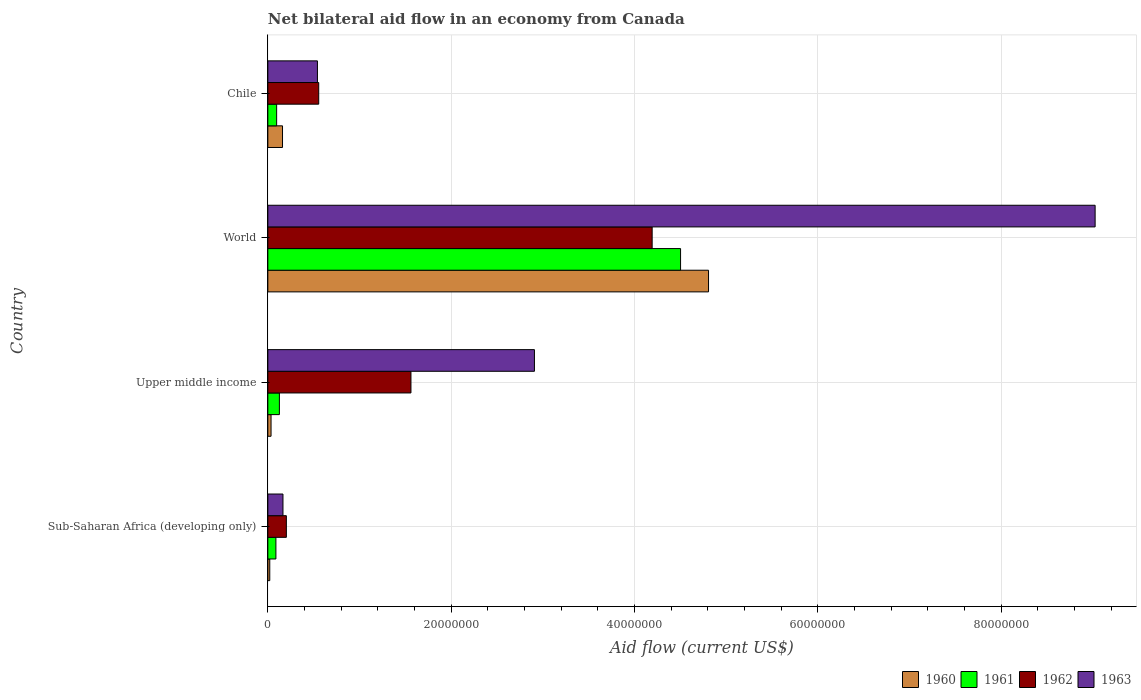Are the number of bars per tick equal to the number of legend labels?
Offer a very short reply. Yes. Are the number of bars on each tick of the Y-axis equal?
Your answer should be very brief. Yes. How many bars are there on the 2nd tick from the top?
Offer a terse response. 4. In how many cases, is the number of bars for a given country not equal to the number of legend labels?
Your response must be concise. 0. What is the net bilateral aid flow in 1963 in World?
Make the answer very short. 9.02e+07. Across all countries, what is the maximum net bilateral aid flow in 1963?
Offer a very short reply. 9.02e+07. Across all countries, what is the minimum net bilateral aid flow in 1962?
Offer a terse response. 2.02e+06. In which country was the net bilateral aid flow in 1962 minimum?
Make the answer very short. Sub-Saharan Africa (developing only). What is the total net bilateral aid flow in 1961 in the graph?
Keep it short and to the point. 4.81e+07. What is the difference between the net bilateral aid flow in 1960 in Chile and that in World?
Your answer should be very brief. -4.65e+07. What is the difference between the net bilateral aid flow in 1962 in World and the net bilateral aid flow in 1961 in Upper middle income?
Offer a terse response. 4.07e+07. What is the average net bilateral aid flow in 1960 per country?
Provide a short and direct response. 1.26e+07. What is the difference between the net bilateral aid flow in 1962 and net bilateral aid flow in 1961 in Chile?
Offer a terse response. 4.59e+06. In how many countries, is the net bilateral aid flow in 1963 greater than 88000000 US$?
Offer a terse response. 1. What is the ratio of the net bilateral aid flow in 1962 in Sub-Saharan Africa (developing only) to that in World?
Your answer should be compact. 0.05. Is the net bilateral aid flow in 1962 in Chile less than that in Sub-Saharan Africa (developing only)?
Your answer should be compact. No. Is the difference between the net bilateral aid flow in 1962 in Sub-Saharan Africa (developing only) and World greater than the difference between the net bilateral aid flow in 1961 in Sub-Saharan Africa (developing only) and World?
Your response must be concise. Yes. What is the difference between the highest and the second highest net bilateral aid flow in 1961?
Provide a short and direct response. 4.38e+07. What is the difference between the highest and the lowest net bilateral aid flow in 1961?
Provide a short and direct response. 4.41e+07. In how many countries, is the net bilateral aid flow in 1962 greater than the average net bilateral aid flow in 1962 taken over all countries?
Your answer should be very brief. 1. Is the sum of the net bilateral aid flow in 1963 in Chile and World greater than the maximum net bilateral aid flow in 1962 across all countries?
Make the answer very short. Yes. Is it the case that in every country, the sum of the net bilateral aid flow in 1960 and net bilateral aid flow in 1963 is greater than the sum of net bilateral aid flow in 1961 and net bilateral aid flow in 1962?
Offer a very short reply. No. What does the 4th bar from the top in Chile represents?
Your answer should be compact. 1960. Is it the case that in every country, the sum of the net bilateral aid flow in 1962 and net bilateral aid flow in 1963 is greater than the net bilateral aid flow in 1961?
Keep it short and to the point. Yes. How many countries are there in the graph?
Provide a short and direct response. 4. Does the graph contain any zero values?
Keep it short and to the point. No. Does the graph contain grids?
Make the answer very short. Yes. How are the legend labels stacked?
Your response must be concise. Horizontal. What is the title of the graph?
Your answer should be compact. Net bilateral aid flow in an economy from Canada. Does "1996" appear as one of the legend labels in the graph?
Provide a succinct answer. No. What is the label or title of the X-axis?
Offer a terse response. Aid flow (current US$). What is the Aid flow (current US$) in 1961 in Sub-Saharan Africa (developing only)?
Offer a terse response. 8.80e+05. What is the Aid flow (current US$) of 1962 in Sub-Saharan Africa (developing only)?
Make the answer very short. 2.02e+06. What is the Aid flow (current US$) of 1963 in Sub-Saharan Africa (developing only)?
Your answer should be compact. 1.65e+06. What is the Aid flow (current US$) of 1960 in Upper middle income?
Make the answer very short. 3.50e+05. What is the Aid flow (current US$) in 1961 in Upper middle income?
Ensure brevity in your answer.  1.26e+06. What is the Aid flow (current US$) of 1962 in Upper middle income?
Make the answer very short. 1.56e+07. What is the Aid flow (current US$) in 1963 in Upper middle income?
Keep it short and to the point. 2.91e+07. What is the Aid flow (current US$) in 1960 in World?
Offer a very short reply. 4.81e+07. What is the Aid flow (current US$) of 1961 in World?
Keep it short and to the point. 4.50e+07. What is the Aid flow (current US$) of 1962 in World?
Provide a succinct answer. 4.19e+07. What is the Aid flow (current US$) of 1963 in World?
Ensure brevity in your answer.  9.02e+07. What is the Aid flow (current US$) of 1960 in Chile?
Keep it short and to the point. 1.60e+06. What is the Aid flow (current US$) in 1961 in Chile?
Keep it short and to the point. 9.60e+05. What is the Aid flow (current US$) of 1962 in Chile?
Your response must be concise. 5.55e+06. What is the Aid flow (current US$) of 1963 in Chile?
Give a very brief answer. 5.41e+06. Across all countries, what is the maximum Aid flow (current US$) of 1960?
Your answer should be very brief. 4.81e+07. Across all countries, what is the maximum Aid flow (current US$) of 1961?
Make the answer very short. 4.50e+07. Across all countries, what is the maximum Aid flow (current US$) of 1962?
Offer a terse response. 4.19e+07. Across all countries, what is the maximum Aid flow (current US$) of 1963?
Provide a short and direct response. 9.02e+07. Across all countries, what is the minimum Aid flow (current US$) in 1960?
Give a very brief answer. 2.10e+05. Across all countries, what is the minimum Aid flow (current US$) in 1961?
Your answer should be compact. 8.80e+05. Across all countries, what is the minimum Aid flow (current US$) of 1962?
Your response must be concise. 2.02e+06. Across all countries, what is the minimum Aid flow (current US$) of 1963?
Your answer should be very brief. 1.65e+06. What is the total Aid flow (current US$) in 1960 in the graph?
Make the answer very short. 5.02e+07. What is the total Aid flow (current US$) in 1961 in the graph?
Give a very brief answer. 4.81e+07. What is the total Aid flow (current US$) of 1962 in the graph?
Provide a short and direct response. 6.51e+07. What is the total Aid flow (current US$) of 1963 in the graph?
Your response must be concise. 1.26e+08. What is the difference between the Aid flow (current US$) in 1960 in Sub-Saharan Africa (developing only) and that in Upper middle income?
Make the answer very short. -1.40e+05. What is the difference between the Aid flow (current US$) in 1961 in Sub-Saharan Africa (developing only) and that in Upper middle income?
Give a very brief answer. -3.80e+05. What is the difference between the Aid flow (current US$) in 1962 in Sub-Saharan Africa (developing only) and that in Upper middle income?
Give a very brief answer. -1.36e+07. What is the difference between the Aid flow (current US$) of 1963 in Sub-Saharan Africa (developing only) and that in Upper middle income?
Keep it short and to the point. -2.74e+07. What is the difference between the Aid flow (current US$) of 1960 in Sub-Saharan Africa (developing only) and that in World?
Your answer should be compact. -4.79e+07. What is the difference between the Aid flow (current US$) of 1961 in Sub-Saharan Africa (developing only) and that in World?
Provide a succinct answer. -4.41e+07. What is the difference between the Aid flow (current US$) of 1962 in Sub-Saharan Africa (developing only) and that in World?
Provide a short and direct response. -3.99e+07. What is the difference between the Aid flow (current US$) in 1963 in Sub-Saharan Africa (developing only) and that in World?
Make the answer very short. -8.86e+07. What is the difference between the Aid flow (current US$) of 1960 in Sub-Saharan Africa (developing only) and that in Chile?
Your answer should be compact. -1.39e+06. What is the difference between the Aid flow (current US$) of 1961 in Sub-Saharan Africa (developing only) and that in Chile?
Provide a succinct answer. -8.00e+04. What is the difference between the Aid flow (current US$) of 1962 in Sub-Saharan Africa (developing only) and that in Chile?
Keep it short and to the point. -3.53e+06. What is the difference between the Aid flow (current US$) in 1963 in Sub-Saharan Africa (developing only) and that in Chile?
Offer a very short reply. -3.76e+06. What is the difference between the Aid flow (current US$) in 1960 in Upper middle income and that in World?
Your answer should be very brief. -4.77e+07. What is the difference between the Aid flow (current US$) of 1961 in Upper middle income and that in World?
Offer a very short reply. -4.38e+07. What is the difference between the Aid flow (current US$) of 1962 in Upper middle income and that in World?
Make the answer very short. -2.63e+07. What is the difference between the Aid flow (current US$) in 1963 in Upper middle income and that in World?
Offer a terse response. -6.12e+07. What is the difference between the Aid flow (current US$) of 1960 in Upper middle income and that in Chile?
Offer a very short reply. -1.25e+06. What is the difference between the Aid flow (current US$) in 1961 in Upper middle income and that in Chile?
Your response must be concise. 3.00e+05. What is the difference between the Aid flow (current US$) of 1962 in Upper middle income and that in Chile?
Offer a very short reply. 1.01e+07. What is the difference between the Aid flow (current US$) of 1963 in Upper middle income and that in Chile?
Your answer should be very brief. 2.37e+07. What is the difference between the Aid flow (current US$) of 1960 in World and that in Chile?
Offer a very short reply. 4.65e+07. What is the difference between the Aid flow (current US$) of 1961 in World and that in Chile?
Keep it short and to the point. 4.41e+07. What is the difference between the Aid flow (current US$) in 1962 in World and that in Chile?
Keep it short and to the point. 3.64e+07. What is the difference between the Aid flow (current US$) of 1963 in World and that in Chile?
Offer a very short reply. 8.48e+07. What is the difference between the Aid flow (current US$) of 1960 in Sub-Saharan Africa (developing only) and the Aid flow (current US$) of 1961 in Upper middle income?
Give a very brief answer. -1.05e+06. What is the difference between the Aid flow (current US$) in 1960 in Sub-Saharan Africa (developing only) and the Aid flow (current US$) in 1962 in Upper middle income?
Give a very brief answer. -1.54e+07. What is the difference between the Aid flow (current US$) of 1960 in Sub-Saharan Africa (developing only) and the Aid flow (current US$) of 1963 in Upper middle income?
Offer a terse response. -2.89e+07. What is the difference between the Aid flow (current US$) of 1961 in Sub-Saharan Africa (developing only) and the Aid flow (current US$) of 1962 in Upper middle income?
Your answer should be very brief. -1.47e+07. What is the difference between the Aid flow (current US$) in 1961 in Sub-Saharan Africa (developing only) and the Aid flow (current US$) in 1963 in Upper middle income?
Offer a terse response. -2.82e+07. What is the difference between the Aid flow (current US$) in 1962 in Sub-Saharan Africa (developing only) and the Aid flow (current US$) in 1963 in Upper middle income?
Your response must be concise. -2.71e+07. What is the difference between the Aid flow (current US$) of 1960 in Sub-Saharan Africa (developing only) and the Aid flow (current US$) of 1961 in World?
Ensure brevity in your answer.  -4.48e+07. What is the difference between the Aid flow (current US$) in 1960 in Sub-Saharan Africa (developing only) and the Aid flow (current US$) in 1962 in World?
Provide a short and direct response. -4.17e+07. What is the difference between the Aid flow (current US$) of 1960 in Sub-Saharan Africa (developing only) and the Aid flow (current US$) of 1963 in World?
Ensure brevity in your answer.  -9.00e+07. What is the difference between the Aid flow (current US$) of 1961 in Sub-Saharan Africa (developing only) and the Aid flow (current US$) of 1962 in World?
Your answer should be very brief. -4.10e+07. What is the difference between the Aid flow (current US$) in 1961 in Sub-Saharan Africa (developing only) and the Aid flow (current US$) in 1963 in World?
Provide a short and direct response. -8.94e+07. What is the difference between the Aid flow (current US$) of 1962 in Sub-Saharan Africa (developing only) and the Aid flow (current US$) of 1963 in World?
Your answer should be compact. -8.82e+07. What is the difference between the Aid flow (current US$) of 1960 in Sub-Saharan Africa (developing only) and the Aid flow (current US$) of 1961 in Chile?
Offer a terse response. -7.50e+05. What is the difference between the Aid flow (current US$) of 1960 in Sub-Saharan Africa (developing only) and the Aid flow (current US$) of 1962 in Chile?
Provide a short and direct response. -5.34e+06. What is the difference between the Aid flow (current US$) in 1960 in Sub-Saharan Africa (developing only) and the Aid flow (current US$) in 1963 in Chile?
Offer a terse response. -5.20e+06. What is the difference between the Aid flow (current US$) of 1961 in Sub-Saharan Africa (developing only) and the Aid flow (current US$) of 1962 in Chile?
Offer a terse response. -4.67e+06. What is the difference between the Aid flow (current US$) in 1961 in Sub-Saharan Africa (developing only) and the Aid flow (current US$) in 1963 in Chile?
Give a very brief answer. -4.53e+06. What is the difference between the Aid flow (current US$) of 1962 in Sub-Saharan Africa (developing only) and the Aid flow (current US$) of 1963 in Chile?
Provide a short and direct response. -3.39e+06. What is the difference between the Aid flow (current US$) of 1960 in Upper middle income and the Aid flow (current US$) of 1961 in World?
Provide a succinct answer. -4.47e+07. What is the difference between the Aid flow (current US$) of 1960 in Upper middle income and the Aid flow (current US$) of 1962 in World?
Your answer should be compact. -4.16e+07. What is the difference between the Aid flow (current US$) of 1960 in Upper middle income and the Aid flow (current US$) of 1963 in World?
Make the answer very short. -8.99e+07. What is the difference between the Aid flow (current US$) of 1961 in Upper middle income and the Aid flow (current US$) of 1962 in World?
Ensure brevity in your answer.  -4.07e+07. What is the difference between the Aid flow (current US$) in 1961 in Upper middle income and the Aid flow (current US$) in 1963 in World?
Ensure brevity in your answer.  -8.90e+07. What is the difference between the Aid flow (current US$) in 1962 in Upper middle income and the Aid flow (current US$) in 1963 in World?
Provide a short and direct response. -7.46e+07. What is the difference between the Aid flow (current US$) in 1960 in Upper middle income and the Aid flow (current US$) in 1961 in Chile?
Give a very brief answer. -6.10e+05. What is the difference between the Aid flow (current US$) of 1960 in Upper middle income and the Aid flow (current US$) of 1962 in Chile?
Your response must be concise. -5.20e+06. What is the difference between the Aid flow (current US$) in 1960 in Upper middle income and the Aid flow (current US$) in 1963 in Chile?
Give a very brief answer. -5.06e+06. What is the difference between the Aid flow (current US$) of 1961 in Upper middle income and the Aid flow (current US$) of 1962 in Chile?
Provide a succinct answer. -4.29e+06. What is the difference between the Aid flow (current US$) of 1961 in Upper middle income and the Aid flow (current US$) of 1963 in Chile?
Your response must be concise. -4.15e+06. What is the difference between the Aid flow (current US$) of 1962 in Upper middle income and the Aid flow (current US$) of 1963 in Chile?
Your answer should be compact. 1.02e+07. What is the difference between the Aid flow (current US$) in 1960 in World and the Aid flow (current US$) in 1961 in Chile?
Offer a very short reply. 4.71e+07. What is the difference between the Aid flow (current US$) in 1960 in World and the Aid flow (current US$) in 1962 in Chile?
Ensure brevity in your answer.  4.25e+07. What is the difference between the Aid flow (current US$) in 1960 in World and the Aid flow (current US$) in 1963 in Chile?
Provide a short and direct response. 4.27e+07. What is the difference between the Aid flow (current US$) in 1961 in World and the Aid flow (current US$) in 1962 in Chile?
Provide a short and direct response. 3.95e+07. What is the difference between the Aid flow (current US$) in 1961 in World and the Aid flow (current US$) in 1963 in Chile?
Ensure brevity in your answer.  3.96e+07. What is the difference between the Aid flow (current US$) in 1962 in World and the Aid flow (current US$) in 1963 in Chile?
Keep it short and to the point. 3.65e+07. What is the average Aid flow (current US$) in 1960 per country?
Your answer should be very brief. 1.26e+07. What is the average Aid flow (current US$) in 1961 per country?
Provide a succinct answer. 1.20e+07. What is the average Aid flow (current US$) in 1962 per country?
Your answer should be very brief. 1.63e+07. What is the average Aid flow (current US$) of 1963 per country?
Your answer should be compact. 3.16e+07. What is the difference between the Aid flow (current US$) of 1960 and Aid flow (current US$) of 1961 in Sub-Saharan Africa (developing only)?
Ensure brevity in your answer.  -6.70e+05. What is the difference between the Aid flow (current US$) of 1960 and Aid flow (current US$) of 1962 in Sub-Saharan Africa (developing only)?
Your answer should be compact. -1.81e+06. What is the difference between the Aid flow (current US$) of 1960 and Aid flow (current US$) of 1963 in Sub-Saharan Africa (developing only)?
Offer a very short reply. -1.44e+06. What is the difference between the Aid flow (current US$) in 1961 and Aid flow (current US$) in 1962 in Sub-Saharan Africa (developing only)?
Provide a short and direct response. -1.14e+06. What is the difference between the Aid flow (current US$) in 1961 and Aid flow (current US$) in 1963 in Sub-Saharan Africa (developing only)?
Your answer should be very brief. -7.70e+05. What is the difference between the Aid flow (current US$) in 1962 and Aid flow (current US$) in 1963 in Sub-Saharan Africa (developing only)?
Your response must be concise. 3.70e+05. What is the difference between the Aid flow (current US$) of 1960 and Aid flow (current US$) of 1961 in Upper middle income?
Make the answer very short. -9.10e+05. What is the difference between the Aid flow (current US$) in 1960 and Aid flow (current US$) in 1962 in Upper middle income?
Ensure brevity in your answer.  -1.53e+07. What is the difference between the Aid flow (current US$) in 1960 and Aid flow (current US$) in 1963 in Upper middle income?
Offer a terse response. -2.87e+07. What is the difference between the Aid flow (current US$) in 1961 and Aid flow (current US$) in 1962 in Upper middle income?
Offer a terse response. -1.44e+07. What is the difference between the Aid flow (current US$) in 1961 and Aid flow (current US$) in 1963 in Upper middle income?
Ensure brevity in your answer.  -2.78e+07. What is the difference between the Aid flow (current US$) in 1962 and Aid flow (current US$) in 1963 in Upper middle income?
Provide a succinct answer. -1.35e+07. What is the difference between the Aid flow (current US$) in 1960 and Aid flow (current US$) in 1961 in World?
Give a very brief answer. 3.05e+06. What is the difference between the Aid flow (current US$) of 1960 and Aid flow (current US$) of 1962 in World?
Make the answer very short. 6.15e+06. What is the difference between the Aid flow (current US$) of 1960 and Aid flow (current US$) of 1963 in World?
Provide a short and direct response. -4.22e+07. What is the difference between the Aid flow (current US$) of 1961 and Aid flow (current US$) of 1962 in World?
Offer a terse response. 3.10e+06. What is the difference between the Aid flow (current US$) in 1961 and Aid flow (current US$) in 1963 in World?
Keep it short and to the point. -4.52e+07. What is the difference between the Aid flow (current US$) in 1962 and Aid flow (current US$) in 1963 in World?
Provide a succinct answer. -4.83e+07. What is the difference between the Aid flow (current US$) in 1960 and Aid flow (current US$) in 1961 in Chile?
Offer a very short reply. 6.40e+05. What is the difference between the Aid flow (current US$) in 1960 and Aid flow (current US$) in 1962 in Chile?
Provide a short and direct response. -3.95e+06. What is the difference between the Aid flow (current US$) in 1960 and Aid flow (current US$) in 1963 in Chile?
Keep it short and to the point. -3.81e+06. What is the difference between the Aid flow (current US$) of 1961 and Aid flow (current US$) of 1962 in Chile?
Make the answer very short. -4.59e+06. What is the difference between the Aid flow (current US$) in 1961 and Aid flow (current US$) in 1963 in Chile?
Offer a very short reply. -4.45e+06. What is the difference between the Aid flow (current US$) of 1962 and Aid flow (current US$) of 1963 in Chile?
Offer a terse response. 1.40e+05. What is the ratio of the Aid flow (current US$) in 1960 in Sub-Saharan Africa (developing only) to that in Upper middle income?
Provide a short and direct response. 0.6. What is the ratio of the Aid flow (current US$) in 1961 in Sub-Saharan Africa (developing only) to that in Upper middle income?
Offer a very short reply. 0.7. What is the ratio of the Aid flow (current US$) of 1962 in Sub-Saharan Africa (developing only) to that in Upper middle income?
Your response must be concise. 0.13. What is the ratio of the Aid flow (current US$) of 1963 in Sub-Saharan Africa (developing only) to that in Upper middle income?
Make the answer very short. 0.06. What is the ratio of the Aid flow (current US$) in 1960 in Sub-Saharan Africa (developing only) to that in World?
Give a very brief answer. 0. What is the ratio of the Aid flow (current US$) in 1961 in Sub-Saharan Africa (developing only) to that in World?
Provide a succinct answer. 0.02. What is the ratio of the Aid flow (current US$) in 1962 in Sub-Saharan Africa (developing only) to that in World?
Your answer should be compact. 0.05. What is the ratio of the Aid flow (current US$) in 1963 in Sub-Saharan Africa (developing only) to that in World?
Ensure brevity in your answer.  0.02. What is the ratio of the Aid flow (current US$) in 1960 in Sub-Saharan Africa (developing only) to that in Chile?
Provide a succinct answer. 0.13. What is the ratio of the Aid flow (current US$) in 1962 in Sub-Saharan Africa (developing only) to that in Chile?
Offer a very short reply. 0.36. What is the ratio of the Aid flow (current US$) in 1963 in Sub-Saharan Africa (developing only) to that in Chile?
Your answer should be compact. 0.3. What is the ratio of the Aid flow (current US$) in 1960 in Upper middle income to that in World?
Provide a short and direct response. 0.01. What is the ratio of the Aid flow (current US$) in 1961 in Upper middle income to that in World?
Provide a short and direct response. 0.03. What is the ratio of the Aid flow (current US$) in 1962 in Upper middle income to that in World?
Offer a terse response. 0.37. What is the ratio of the Aid flow (current US$) in 1963 in Upper middle income to that in World?
Keep it short and to the point. 0.32. What is the ratio of the Aid flow (current US$) in 1960 in Upper middle income to that in Chile?
Your answer should be compact. 0.22. What is the ratio of the Aid flow (current US$) in 1961 in Upper middle income to that in Chile?
Provide a succinct answer. 1.31. What is the ratio of the Aid flow (current US$) of 1962 in Upper middle income to that in Chile?
Offer a very short reply. 2.81. What is the ratio of the Aid flow (current US$) in 1963 in Upper middle income to that in Chile?
Offer a terse response. 5.38. What is the ratio of the Aid flow (current US$) of 1960 in World to that in Chile?
Make the answer very short. 30.04. What is the ratio of the Aid flow (current US$) in 1961 in World to that in Chile?
Provide a short and direct response. 46.9. What is the ratio of the Aid flow (current US$) of 1962 in World to that in Chile?
Provide a short and direct response. 7.55. What is the ratio of the Aid flow (current US$) in 1963 in World to that in Chile?
Offer a terse response. 16.68. What is the difference between the highest and the second highest Aid flow (current US$) in 1960?
Your answer should be very brief. 4.65e+07. What is the difference between the highest and the second highest Aid flow (current US$) in 1961?
Make the answer very short. 4.38e+07. What is the difference between the highest and the second highest Aid flow (current US$) in 1962?
Provide a short and direct response. 2.63e+07. What is the difference between the highest and the second highest Aid flow (current US$) in 1963?
Give a very brief answer. 6.12e+07. What is the difference between the highest and the lowest Aid flow (current US$) of 1960?
Provide a short and direct response. 4.79e+07. What is the difference between the highest and the lowest Aid flow (current US$) of 1961?
Offer a terse response. 4.41e+07. What is the difference between the highest and the lowest Aid flow (current US$) of 1962?
Offer a very short reply. 3.99e+07. What is the difference between the highest and the lowest Aid flow (current US$) in 1963?
Your answer should be compact. 8.86e+07. 